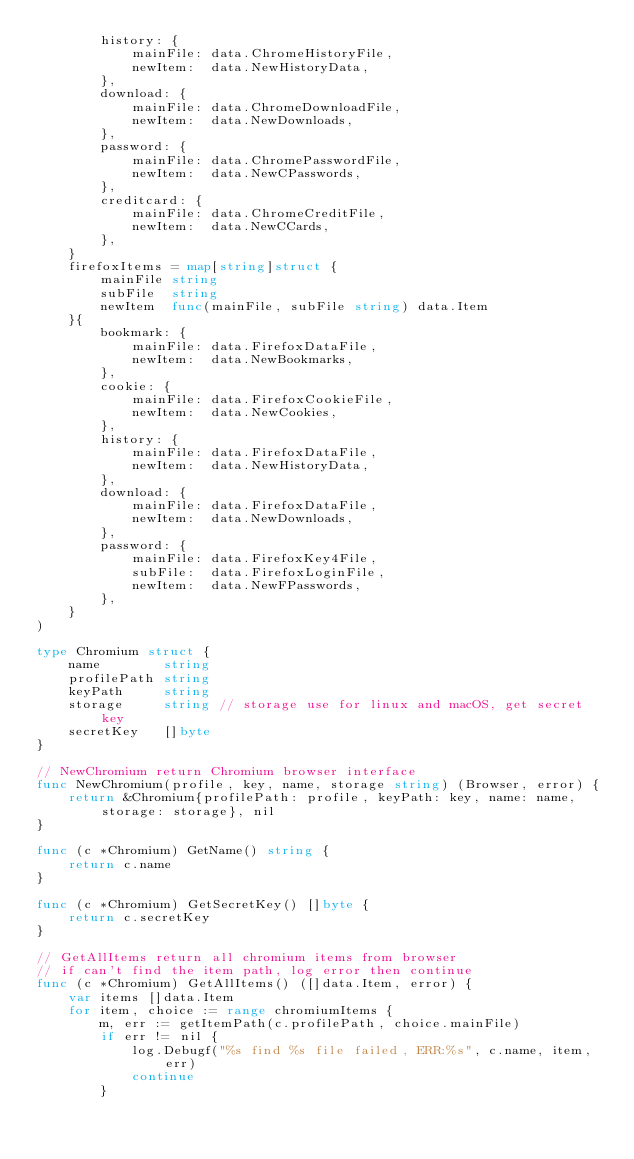Convert code to text. <code><loc_0><loc_0><loc_500><loc_500><_Go_>		history: {
			mainFile: data.ChromeHistoryFile,
			newItem:  data.NewHistoryData,
		},
		download: {
			mainFile: data.ChromeDownloadFile,
			newItem:  data.NewDownloads,
		},
		password: {
			mainFile: data.ChromePasswordFile,
			newItem:  data.NewCPasswords,
		},
		creditcard: {
			mainFile: data.ChromeCreditFile,
			newItem:  data.NewCCards,
		},
	}
	firefoxItems = map[string]struct {
		mainFile string
		subFile  string
		newItem  func(mainFile, subFile string) data.Item
	}{
		bookmark: {
			mainFile: data.FirefoxDataFile,
			newItem:  data.NewBookmarks,
		},
		cookie: {
			mainFile: data.FirefoxCookieFile,
			newItem:  data.NewCookies,
		},
		history: {
			mainFile: data.FirefoxDataFile,
			newItem:  data.NewHistoryData,
		},
		download: {
			mainFile: data.FirefoxDataFile,
			newItem:  data.NewDownloads,
		},
		password: {
			mainFile: data.FirefoxKey4File,
			subFile:  data.FirefoxLoginFile,
			newItem:  data.NewFPasswords,
		},
	}
)

type Chromium struct {
	name        string
	profilePath string
	keyPath     string
	storage     string // storage use for linux and macOS, get secret key
	secretKey   []byte
}

// NewChromium return Chromium browser interface
func NewChromium(profile, key, name, storage string) (Browser, error) {
	return &Chromium{profilePath: profile, keyPath: key, name: name, storage: storage}, nil
}

func (c *Chromium) GetName() string {
	return c.name
}

func (c *Chromium) GetSecretKey() []byte {
	return c.secretKey
}

// GetAllItems return all chromium items from browser
// if can't find the item path, log error then continue
func (c *Chromium) GetAllItems() ([]data.Item, error) {
	var items []data.Item
	for item, choice := range chromiumItems {
		m, err := getItemPath(c.profilePath, choice.mainFile)
		if err != nil {
			log.Debugf("%s find %s file failed, ERR:%s", c.name, item, err)
			continue
		}</code> 